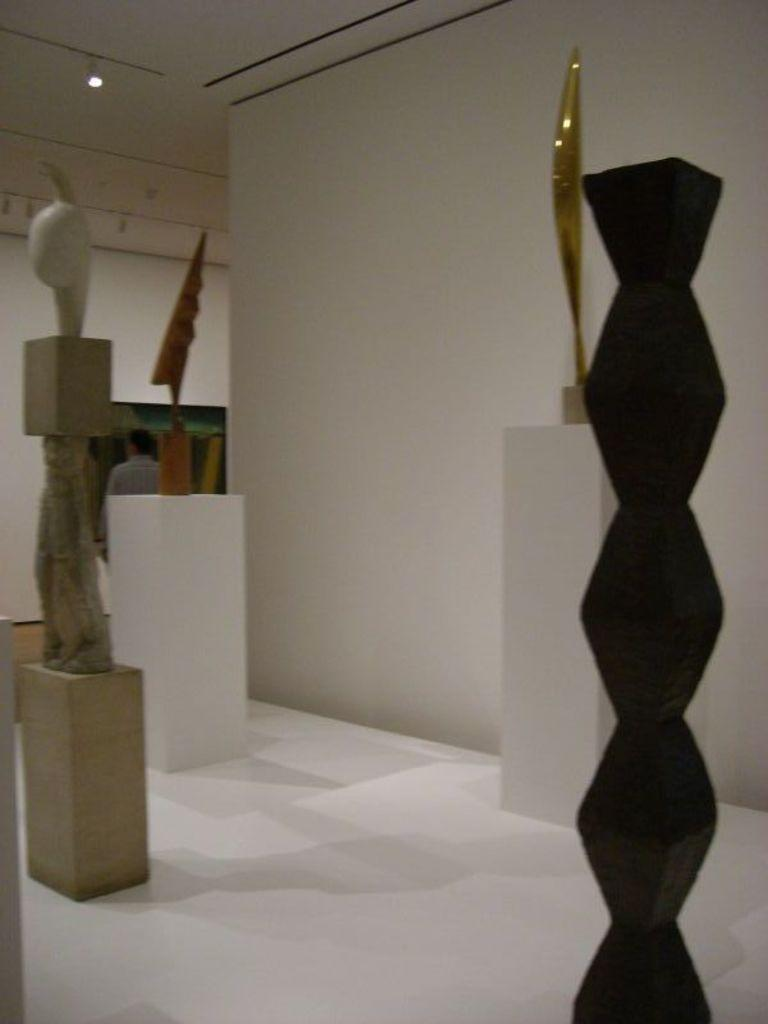What type of art is present in the image? There are sculptures in the image. What can be seen in the background of the image? There is a wall and a person in the background of the image. Where is the light located in the image? The light is at the top of the image. What type of tooth is being exchanged by the farmer in the image? There is no farmer or tooth present in the image. 